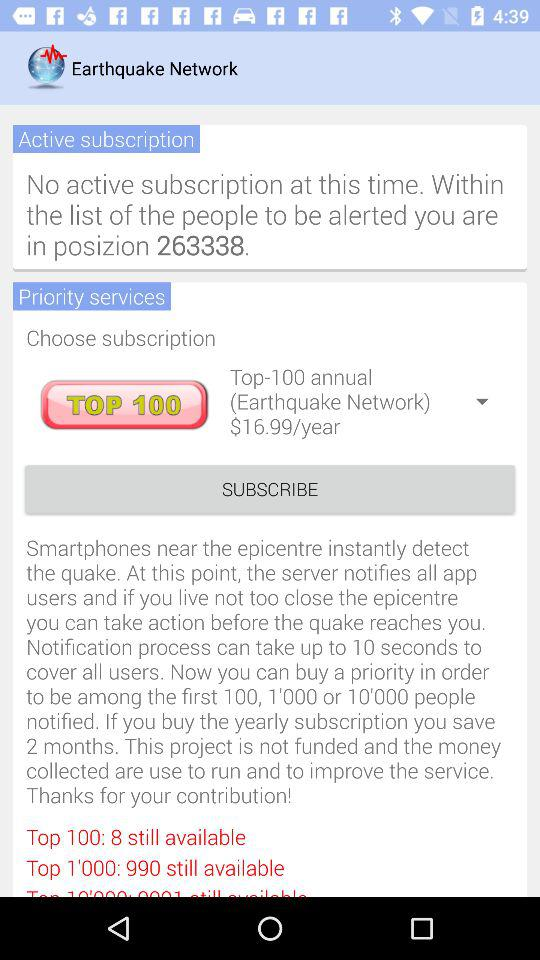How many more people are available for the top 1000 subscription than the top 100?
Answer the question using a single word or phrase. 982 